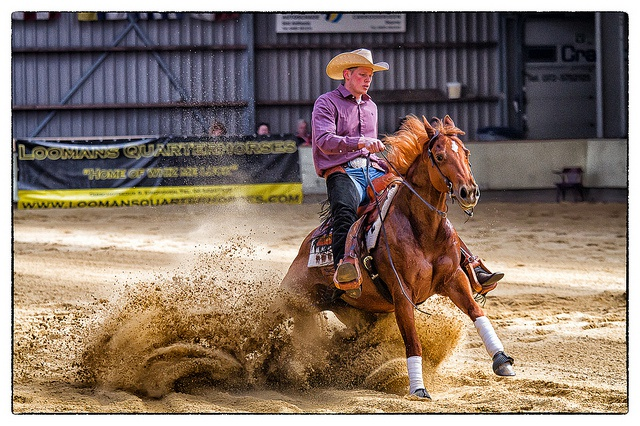Describe the objects in this image and their specific colors. I can see horse in white, maroon, black, and brown tones, people in white, black, purple, and maroon tones, people in white, purple, and black tones, people in white, gray, and black tones, and people in white, black, purple, and gray tones in this image. 